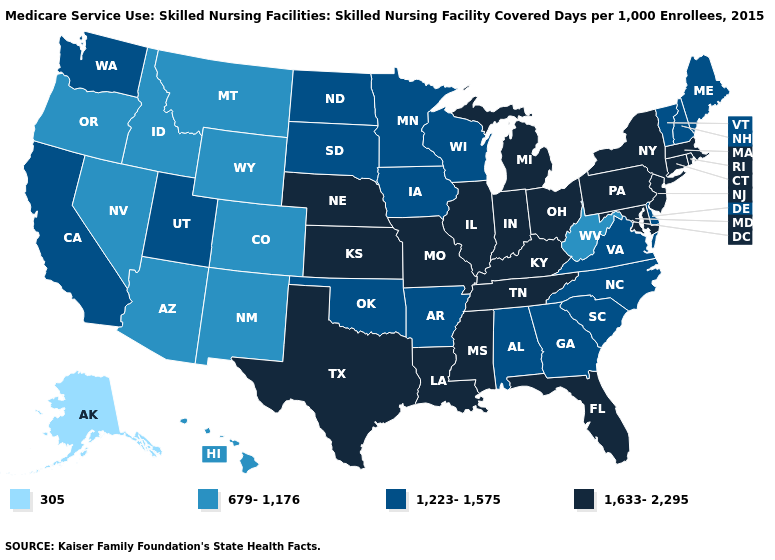Among the states that border Arkansas , does Oklahoma have the lowest value?
Short answer required. Yes. Does North Carolina have the lowest value in the USA?
Be succinct. No. What is the highest value in states that border Oregon?
Quick response, please. 1,223-1,575. What is the value of California?
Give a very brief answer. 1,223-1,575. What is the highest value in the USA?
Give a very brief answer. 1,633-2,295. What is the lowest value in the South?
Be succinct. 679-1,176. Which states have the lowest value in the USA?
Write a very short answer. Alaska. Among the states that border New Hampshire , which have the highest value?
Be succinct. Massachusetts. Which states have the lowest value in the MidWest?
Concise answer only. Iowa, Minnesota, North Dakota, South Dakota, Wisconsin. Name the states that have a value in the range 679-1,176?
Concise answer only. Arizona, Colorado, Hawaii, Idaho, Montana, Nevada, New Mexico, Oregon, West Virginia, Wyoming. Name the states that have a value in the range 1,633-2,295?
Give a very brief answer. Connecticut, Florida, Illinois, Indiana, Kansas, Kentucky, Louisiana, Maryland, Massachusetts, Michigan, Mississippi, Missouri, Nebraska, New Jersey, New York, Ohio, Pennsylvania, Rhode Island, Tennessee, Texas. Does the map have missing data?
Give a very brief answer. No. Does Idaho have the highest value in the West?
Concise answer only. No. What is the value of Tennessee?
Concise answer only. 1,633-2,295. Among the states that border Texas , which have the lowest value?
Write a very short answer. New Mexico. 